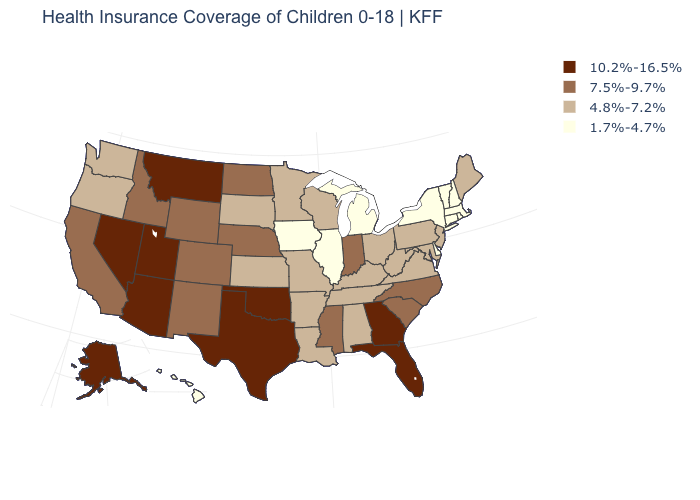Among the states that border Washington , which have the lowest value?
Keep it brief. Oregon. Among the states that border Maryland , which have the lowest value?
Give a very brief answer. Delaware. How many symbols are there in the legend?
Concise answer only. 4. Does Texas have a higher value than Wisconsin?
Short answer required. Yes. What is the value of South Carolina?
Give a very brief answer. 7.5%-9.7%. Among the states that border Minnesota , which have the highest value?
Give a very brief answer. North Dakota. What is the lowest value in the South?
Keep it brief. 1.7%-4.7%. What is the lowest value in the MidWest?
Short answer required. 1.7%-4.7%. What is the highest value in the Northeast ?
Short answer required. 4.8%-7.2%. Does the first symbol in the legend represent the smallest category?
Answer briefly. No. Which states have the highest value in the USA?
Keep it brief. Alaska, Arizona, Florida, Georgia, Montana, Nevada, Oklahoma, Texas, Utah. Does Hawaii have the highest value in the West?
Concise answer only. No. How many symbols are there in the legend?
Be succinct. 4. What is the highest value in states that border New Mexico?
Give a very brief answer. 10.2%-16.5%. Does Illinois have the lowest value in the USA?
Be succinct. Yes. 